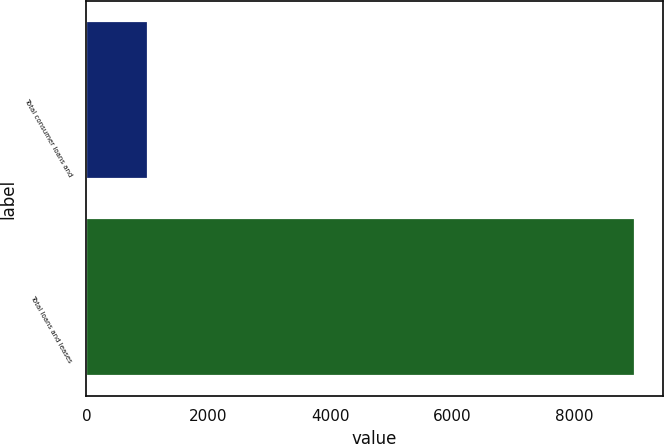Convert chart to OTSL. <chart><loc_0><loc_0><loc_500><loc_500><bar_chart><fcel>Total consumer loans and<fcel>Total loans and leases<nl><fcel>1005<fcel>9002<nl></chart> 